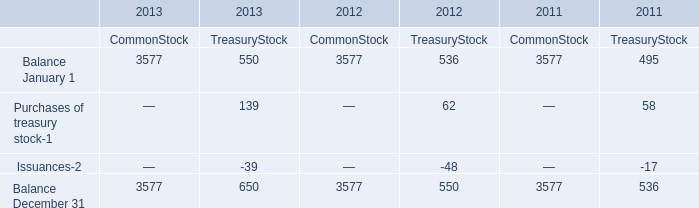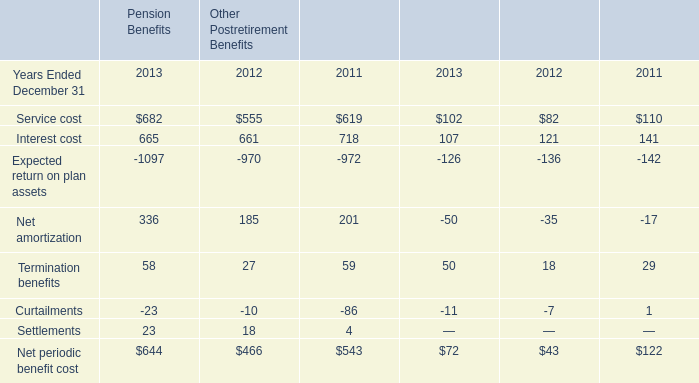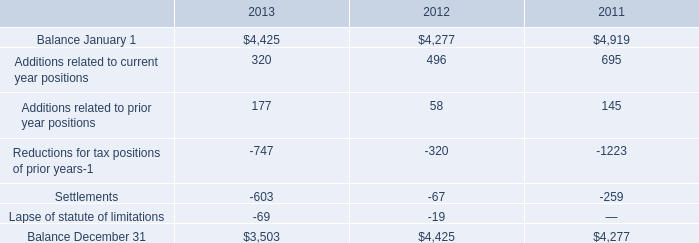what's the total amount of Balance December 31 of 2011 CommonStock, Reductions for tax positions of prior years of 2011, and Balance December 31 of 2013 CommonStock ? 
Computations: ((3577.0 + 1223.0) + 3577.0)
Answer: 8377.0. 